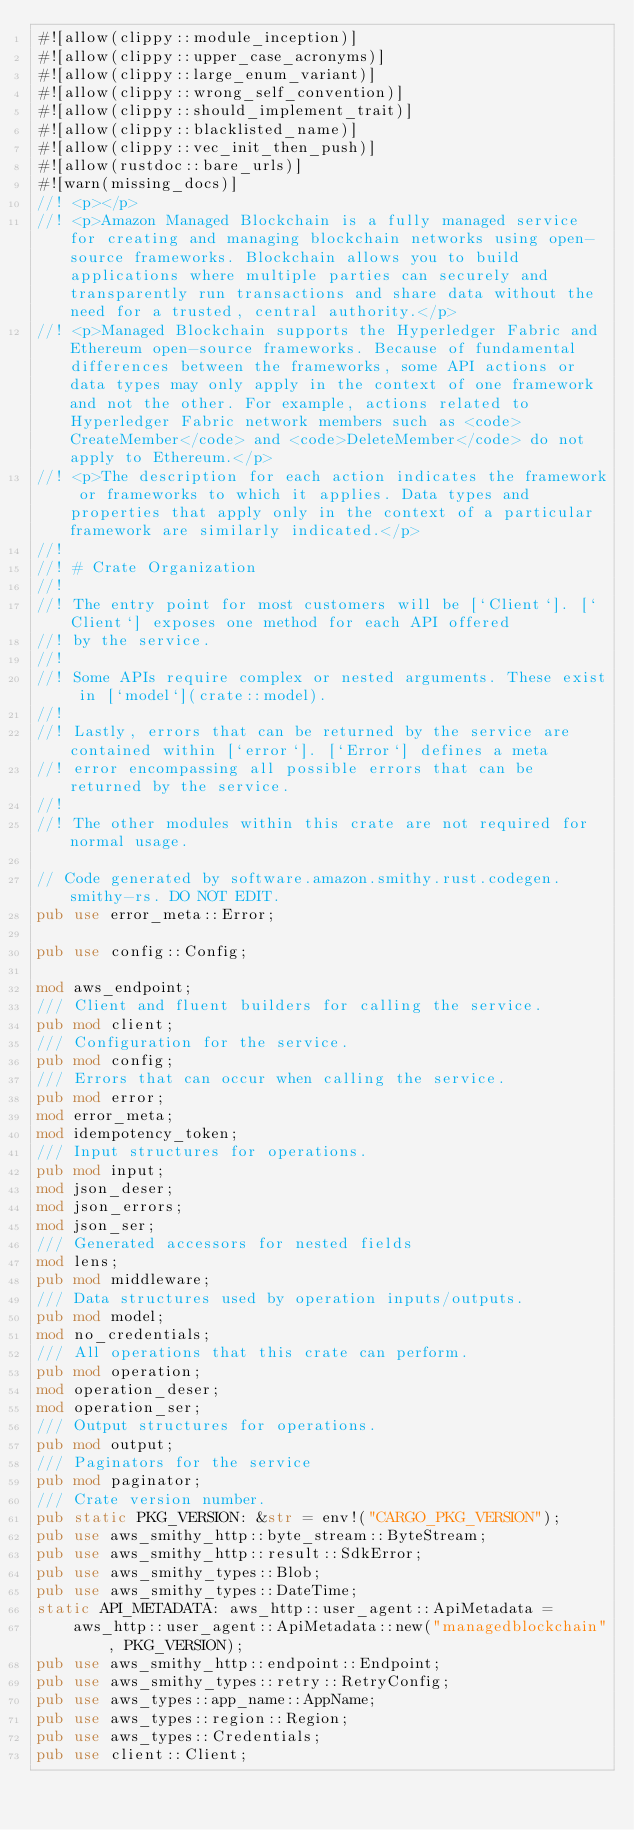Convert code to text. <code><loc_0><loc_0><loc_500><loc_500><_Rust_>#![allow(clippy::module_inception)]
#![allow(clippy::upper_case_acronyms)]
#![allow(clippy::large_enum_variant)]
#![allow(clippy::wrong_self_convention)]
#![allow(clippy::should_implement_trait)]
#![allow(clippy::blacklisted_name)]
#![allow(clippy::vec_init_then_push)]
#![allow(rustdoc::bare_urls)]
#![warn(missing_docs)]
//! <p></p>
//! <p>Amazon Managed Blockchain is a fully managed service for creating and managing blockchain networks using open-source frameworks. Blockchain allows you to build applications where multiple parties can securely and transparently run transactions and share data without the need for a trusted, central authority.</p>
//! <p>Managed Blockchain supports the Hyperledger Fabric and Ethereum open-source frameworks. Because of fundamental differences between the frameworks, some API actions or data types may only apply in the context of one framework and not the other. For example, actions related to Hyperledger Fabric network members such as <code>CreateMember</code> and <code>DeleteMember</code> do not apply to Ethereum.</p>
//! <p>The description for each action indicates the framework or frameworks to which it applies. Data types and properties that apply only in the context of a particular framework are similarly indicated.</p>
//!
//! # Crate Organization
//!
//! The entry point for most customers will be [`Client`]. [`Client`] exposes one method for each API offered
//! by the service.
//!
//! Some APIs require complex or nested arguments. These exist in [`model`](crate::model).
//!
//! Lastly, errors that can be returned by the service are contained within [`error`]. [`Error`] defines a meta
//! error encompassing all possible errors that can be returned by the service.
//!
//! The other modules within this crate are not required for normal usage.

// Code generated by software.amazon.smithy.rust.codegen.smithy-rs. DO NOT EDIT.
pub use error_meta::Error;

pub use config::Config;

mod aws_endpoint;
/// Client and fluent builders for calling the service.
pub mod client;
/// Configuration for the service.
pub mod config;
/// Errors that can occur when calling the service.
pub mod error;
mod error_meta;
mod idempotency_token;
/// Input structures for operations.
pub mod input;
mod json_deser;
mod json_errors;
mod json_ser;
/// Generated accessors for nested fields
mod lens;
pub mod middleware;
/// Data structures used by operation inputs/outputs.
pub mod model;
mod no_credentials;
/// All operations that this crate can perform.
pub mod operation;
mod operation_deser;
mod operation_ser;
/// Output structures for operations.
pub mod output;
/// Paginators for the service
pub mod paginator;
/// Crate version number.
pub static PKG_VERSION: &str = env!("CARGO_PKG_VERSION");
pub use aws_smithy_http::byte_stream::ByteStream;
pub use aws_smithy_http::result::SdkError;
pub use aws_smithy_types::Blob;
pub use aws_smithy_types::DateTime;
static API_METADATA: aws_http::user_agent::ApiMetadata =
    aws_http::user_agent::ApiMetadata::new("managedblockchain", PKG_VERSION);
pub use aws_smithy_http::endpoint::Endpoint;
pub use aws_smithy_types::retry::RetryConfig;
pub use aws_types::app_name::AppName;
pub use aws_types::region::Region;
pub use aws_types::Credentials;
pub use client::Client;
</code> 